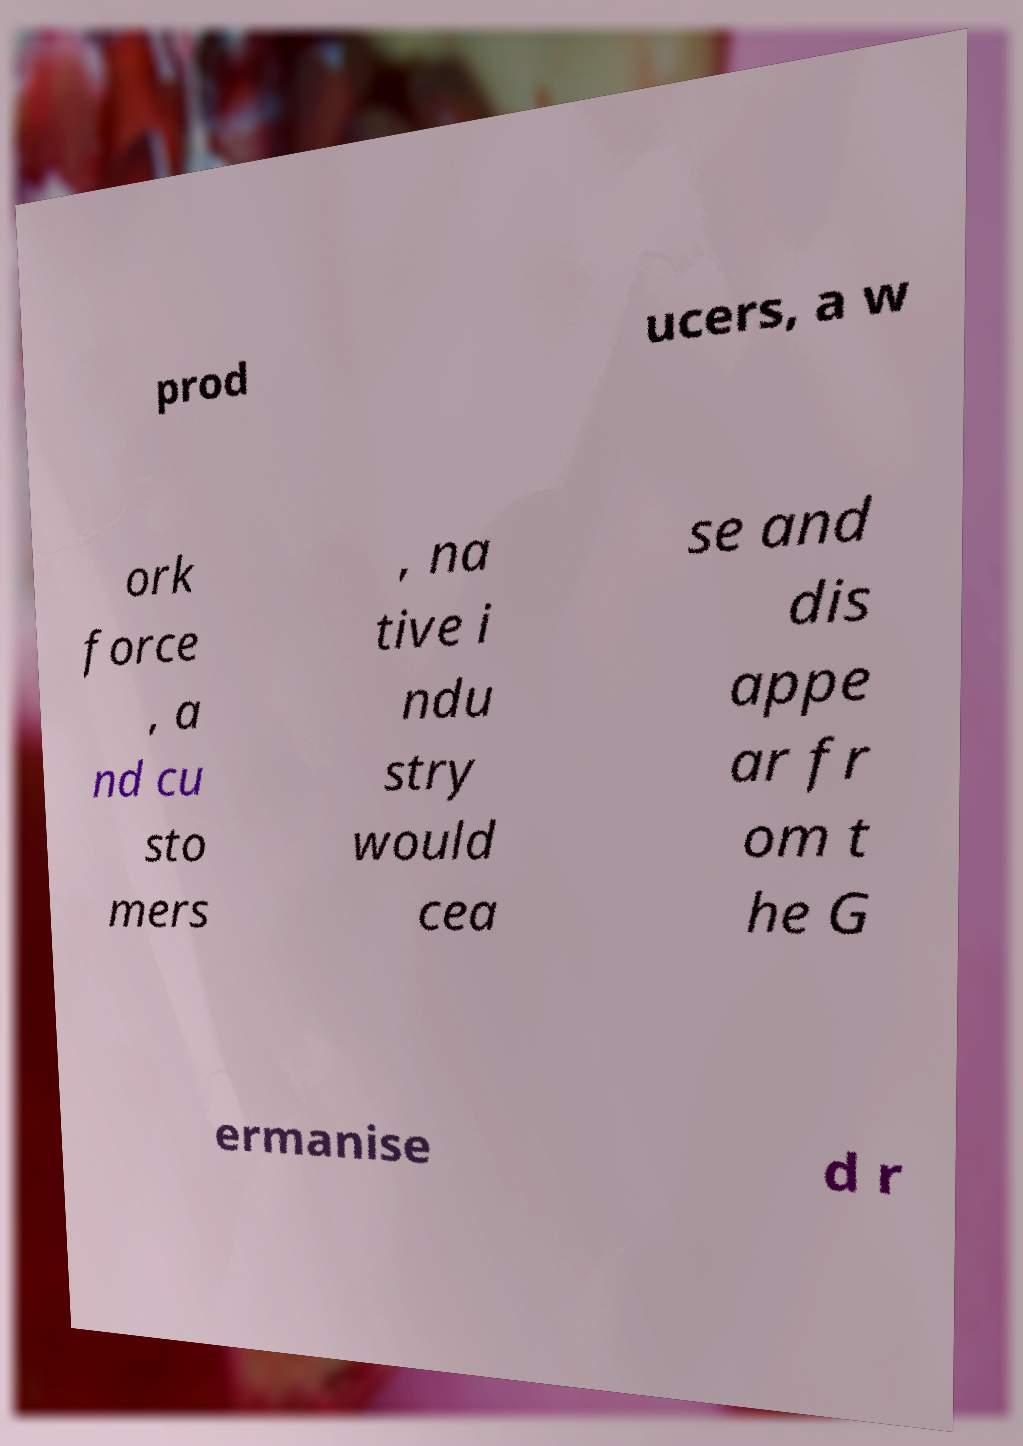What messages or text are displayed in this image? I need them in a readable, typed format. prod ucers, a w ork force , a nd cu sto mers , na tive i ndu stry would cea se and dis appe ar fr om t he G ermanise d r 